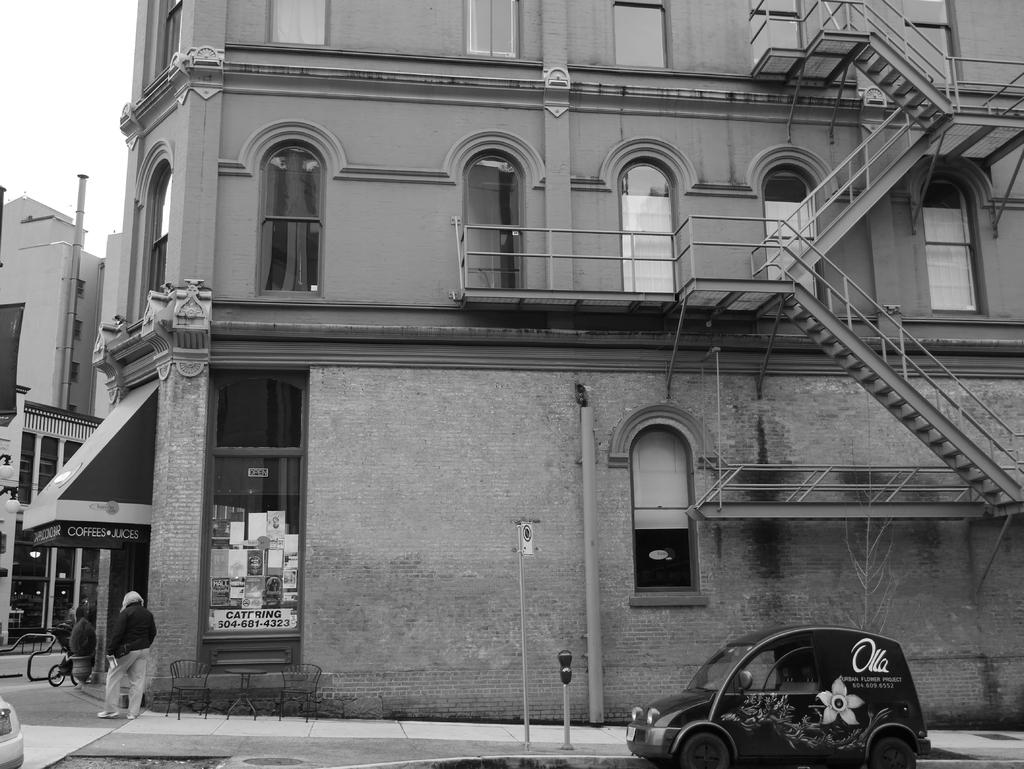What type of structure is present in the image? There is a building in the image. What features can be observed on the building? The building has windows and a staircase. What else is visible in the image besides the building? There are poles and vehicles visible in the image. Are there any people visible in the image? Yes, there is a person visible on the road in the image. What type of trail can be seen in the image? There is no trail present in the image. What committee is responsible for the maintenance of the vehicles in the image? There is no committee mentioned or visible in the image. 